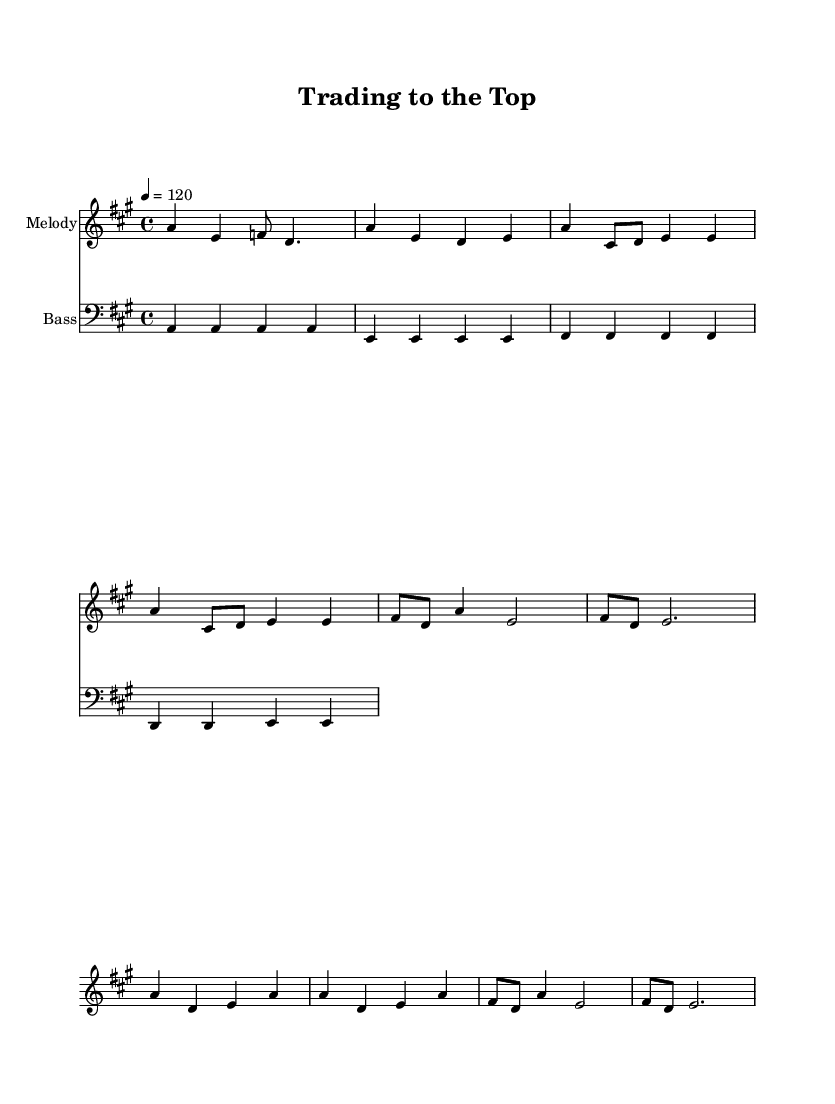What is the key signature of this music? The key signature indicated in the music is A major, which has three sharps (F#, C#, and G#). This is shown by the "key a" instruction present in the global context.
Answer: A major What is the time signature of this music? The time signature is 4/4, which means there are four beats in each measure and the quarter note gets one beat. This is clearly noted in the global context by "\time 4/4."
Answer: 4/4 What is the tempo marking for the piece? The tempo marking is set to 120 beats per minute, denoted by the label "\tempo 4 = 120." This indicates the speed at which the piece should be played.
Answer: 120 How many measures are in the melody section? The melody section consists of a total of eight measures. This can be counted explicitly by observing the notes and their corresponding measures within the melody staff.
Answer: 8 What is the primary musical theme of the lyrics? The primary theme of the lyrics is financial success and trading strategy. This is evident from phrases referring to buying low, selling high, and trading to the top.
Answer: Financial success What type of instrument is indicated for the bassline? The bassline is indicated to be played on a bass clef instrument, which typically includes instruments like the bass guitar or double bass. This is indicated by the "\clef bass" instruction.
Answer: Bass What is the main purpose of the lyrics in this disco song? The main purpose of the lyrics is to celebrate financial achievements and emphasize successful trading strategies, creating an upbeat and motivational atmosphere typical of disco music.
Answer: Celebrate financial achievements 